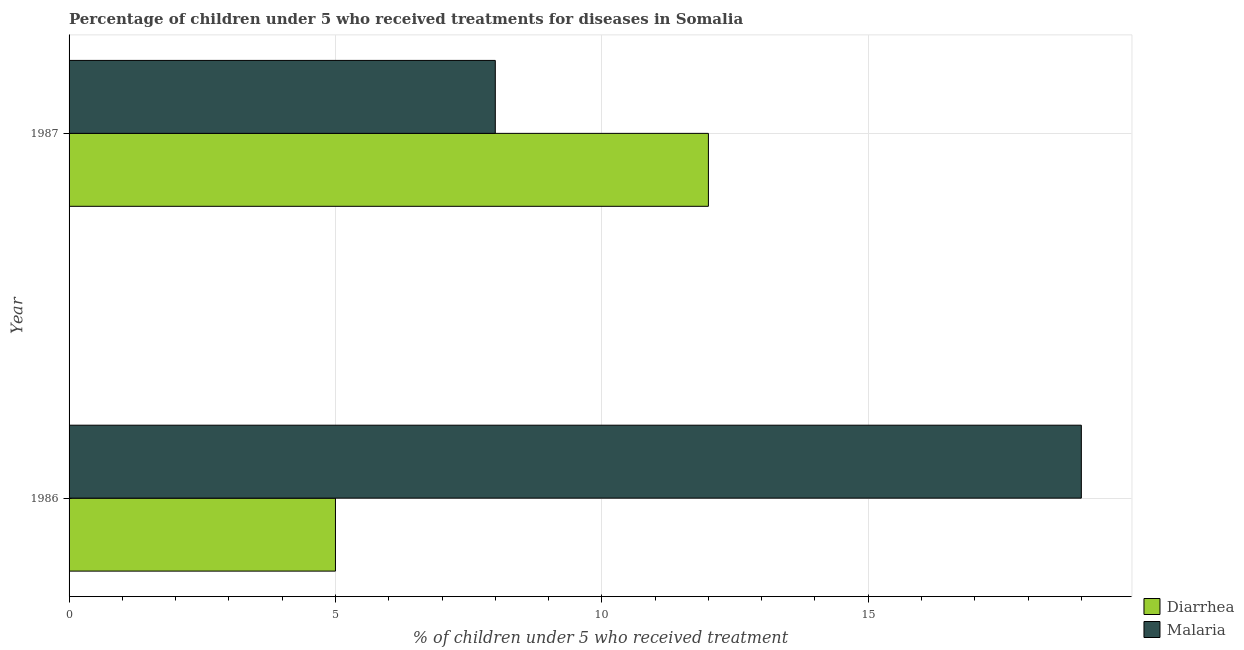How many different coloured bars are there?
Your answer should be very brief. 2. How many groups of bars are there?
Your answer should be compact. 2. In how many cases, is the number of bars for a given year not equal to the number of legend labels?
Provide a succinct answer. 0. What is the percentage of children who received treatment for malaria in 1987?
Offer a very short reply. 8. Across all years, what is the maximum percentage of children who received treatment for diarrhoea?
Give a very brief answer. 12. Across all years, what is the minimum percentage of children who received treatment for malaria?
Ensure brevity in your answer.  8. In which year was the percentage of children who received treatment for diarrhoea minimum?
Your answer should be compact. 1986. What is the total percentage of children who received treatment for diarrhoea in the graph?
Give a very brief answer. 17. What is the difference between the percentage of children who received treatment for malaria in 1986 and that in 1987?
Your answer should be very brief. 11. What is the difference between the percentage of children who received treatment for malaria in 1987 and the percentage of children who received treatment for diarrhoea in 1986?
Keep it short and to the point. 3. In the year 1986, what is the difference between the percentage of children who received treatment for diarrhoea and percentage of children who received treatment for malaria?
Keep it short and to the point. -14. In how many years, is the percentage of children who received treatment for malaria greater than 4 %?
Offer a very short reply. 2. What is the ratio of the percentage of children who received treatment for malaria in 1986 to that in 1987?
Provide a succinct answer. 2.38. Is the percentage of children who received treatment for diarrhoea in 1986 less than that in 1987?
Make the answer very short. Yes. What does the 2nd bar from the top in 1986 represents?
Offer a very short reply. Diarrhea. What does the 2nd bar from the bottom in 1987 represents?
Ensure brevity in your answer.  Malaria. How many years are there in the graph?
Give a very brief answer. 2. Does the graph contain any zero values?
Keep it short and to the point. No. Where does the legend appear in the graph?
Provide a succinct answer. Bottom right. How many legend labels are there?
Your answer should be very brief. 2. How are the legend labels stacked?
Your answer should be compact. Vertical. What is the title of the graph?
Provide a short and direct response. Percentage of children under 5 who received treatments for diseases in Somalia. Does "Age 65(male)" appear as one of the legend labels in the graph?
Offer a very short reply. No. What is the label or title of the X-axis?
Provide a short and direct response. % of children under 5 who received treatment. What is the label or title of the Y-axis?
Offer a terse response. Year. Across all years, what is the maximum % of children under 5 who received treatment of Diarrhea?
Your answer should be compact. 12. Across all years, what is the maximum % of children under 5 who received treatment in Malaria?
Your answer should be compact. 19. Across all years, what is the minimum % of children under 5 who received treatment in Malaria?
Your answer should be compact. 8. What is the total % of children under 5 who received treatment of Malaria in the graph?
Your answer should be very brief. 27. What is the difference between the % of children under 5 who received treatment in Diarrhea in 1986 and that in 1987?
Your answer should be very brief. -7. What is the difference between the % of children under 5 who received treatment in Malaria in 1986 and that in 1987?
Provide a succinct answer. 11. What is the difference between the % of children under 5 who received treatment in Diarrhea in 1986 and the % of children under 5 who received treatment in Malaria in 1987?
Your response must be concise. -3. What is the average % of children under 5 who received treatment of Malaria per year?
Offer a very short reply. 13.5. In the year 1986, what is the difference between the % of children under 5 who received treatment in Diarrhea and % of children under 5 who received treatment in Malaria?
Ensure brevity in your answer.  -14. In the year 1987, what is the difference between the % of children under 5 who received treatment in Diarrhea and % of children under 5 who received treatment in Malaria?
Provide a succinct answer. 4. What is the ratio of the % of children under 5 who received treatment in Diarrhea in 1986 to that in 1987?
Keep it short and to the point. 0.42. What is the ratio of the % of children under 5 who received treatment in Malaria in 1986 to that in 1987?
Provide a succinct answer. 2.38. What is the difference between the highest and the lowest % of children under 5 who received treatment of Diarrhea?
Your answer should be compact. 7. 